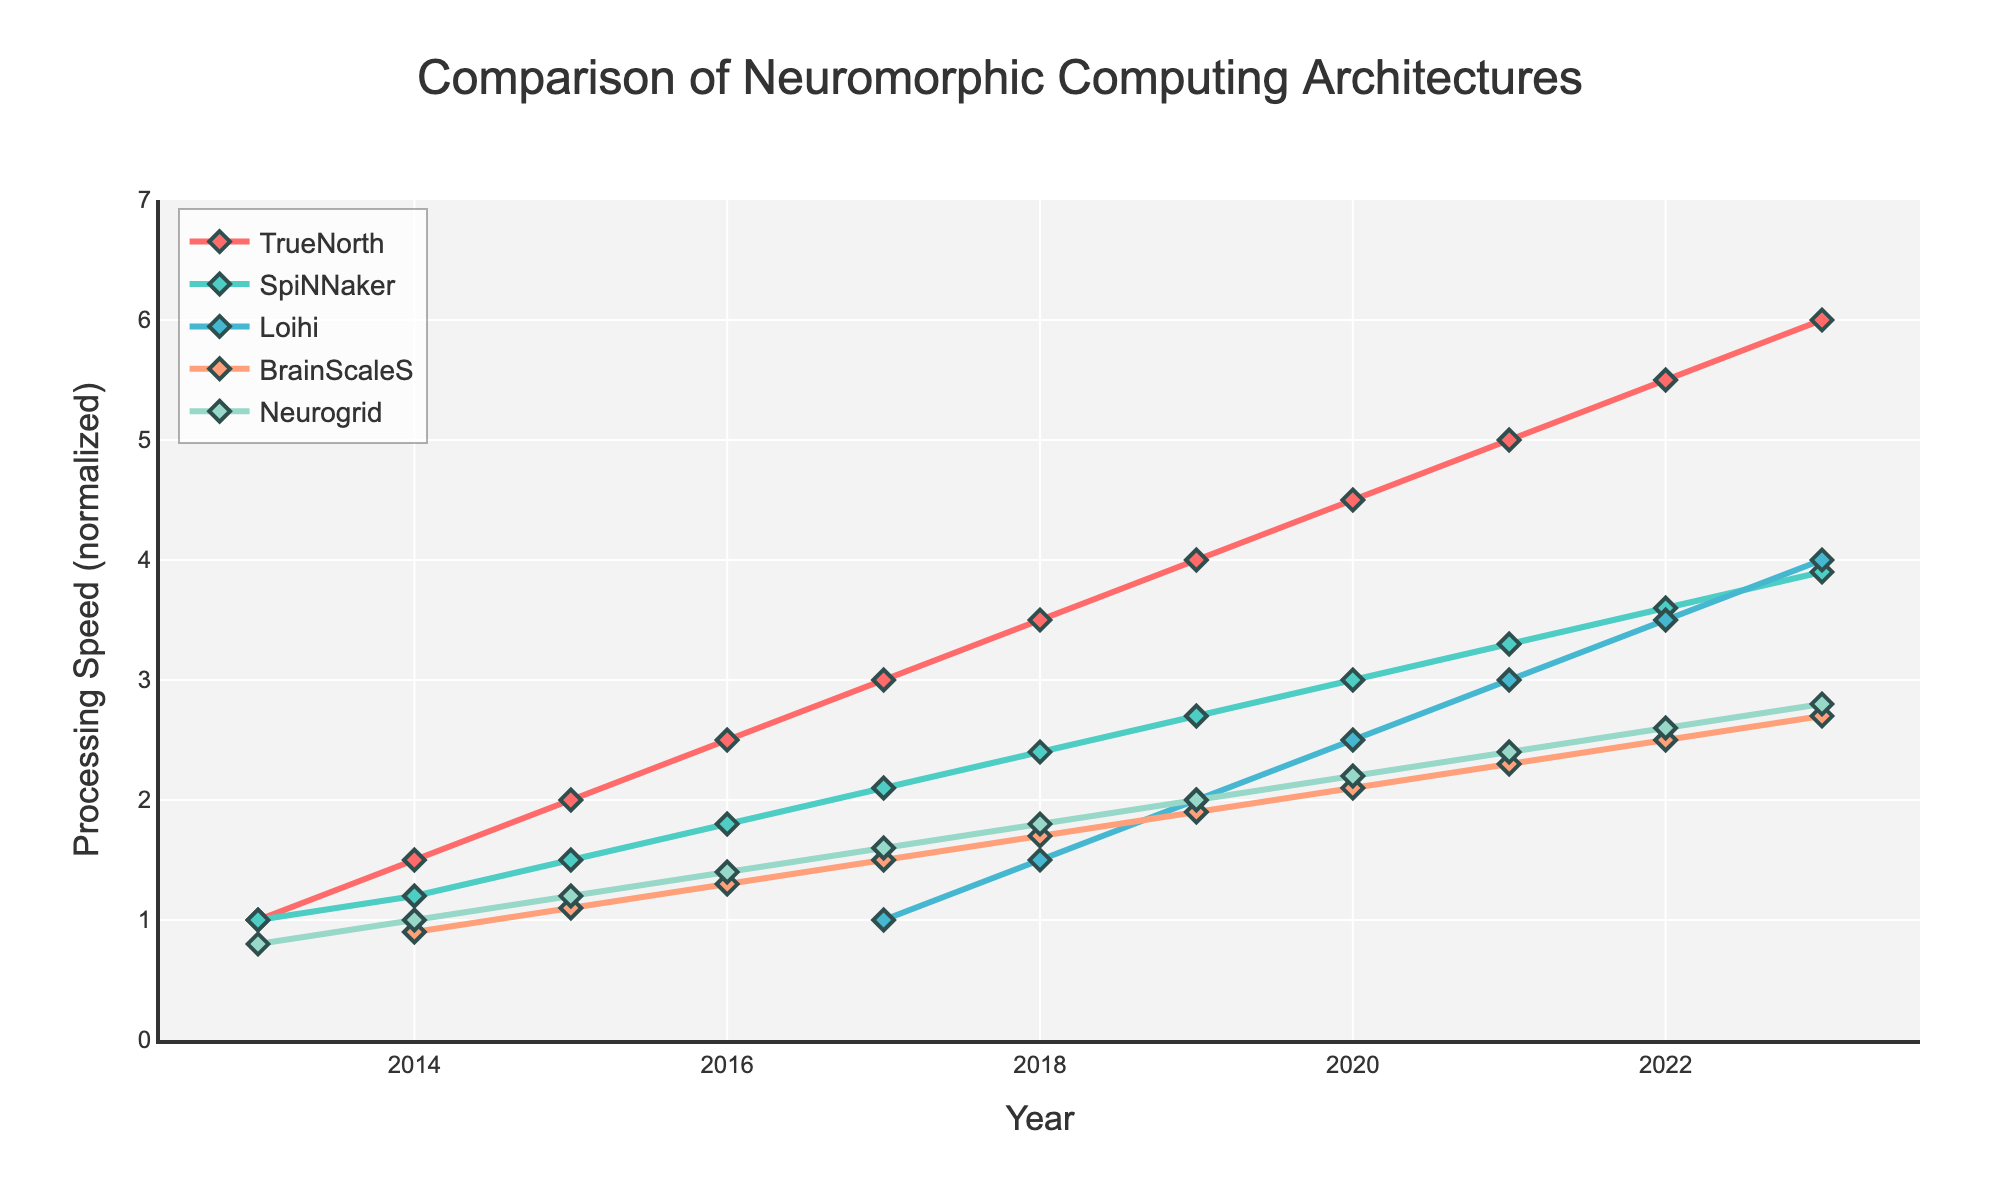What is the processing speed of TrueNorth in 2016? In the plot, locate the 2016 value on the x-axis and check the corresponding y-value for TrueNorth, which is marked with a line in red.
Answer: 2.5 Which neuromorphic architecture had the highest processing speed in 2018? Find the 2018 value on the x-axis and compare the y-values for all the architectures in that year. The architecture with the highest y-value is the one with the highest processing speed.
Answer: TrueNorth Between 2014 and 2016, what is the net increase in processing speed for SpiNNaker? Check the y-values for SpiNNaker in 2014 and 2016. Subtract the 2014 value from the 2016 value: 1.8 - 1.2 = 0.6.
Answer: 0.6 Which architecture showed the greatest growth in processing speed from 2017 to 2023? Calculate the increase in processing speed from 2017 to 2023 for each architecture by subtracting the 2017 values from the 2023 values. The architecture with the largest difference is the one with the greatest growth.
Answer: TrueNorth In which year did Loihi first appear in the figure, and what was its processing speed that year? Identify the first year that Loihi has a y-value (non-missing data). This is when it first appeared in the figure. Check the corresponding processing speed.
Answer: 2017, 1 Comparing TrueNorth and BrainScaleS, which architecture had a higher average processing speed over the entire period? Compute the average processing speed for each architecture by summing their y-values and then dividing by the number of years measured. Compare the averages of TrueNorth and BrainScaleS.
Answer: TrueNorth Which architecture had the smallest processing speed in 2019? Find the 2019 value on the x-axis and compare the y-values for all the architectures in that year. The architecture with the smallest y-value is the one with the smallest processing speed.
Answer: BrainScaleS How does the processing speed of Neurogrid in 2022 compare to its speed in 2018? Check the y-values for Neurogrid in 2022 and 2018, then calculate the difference: y(2022) - y(2018) = 2.6 - 1.8 = 0.8. Neurogrid's speed increased by 0.8.
Answer: Increased by 0.8 What is the average processing speed of Loihi from 2017 to 2023? Identify the y-values for Loihi from 2017 to 2023, then compute the average by summing these values and dividing by the number of values: (1 + 1.5 + 2 + 2.5 + 3 + 3.5 + 4)/7 = 2.5.
Answer: 2.5 